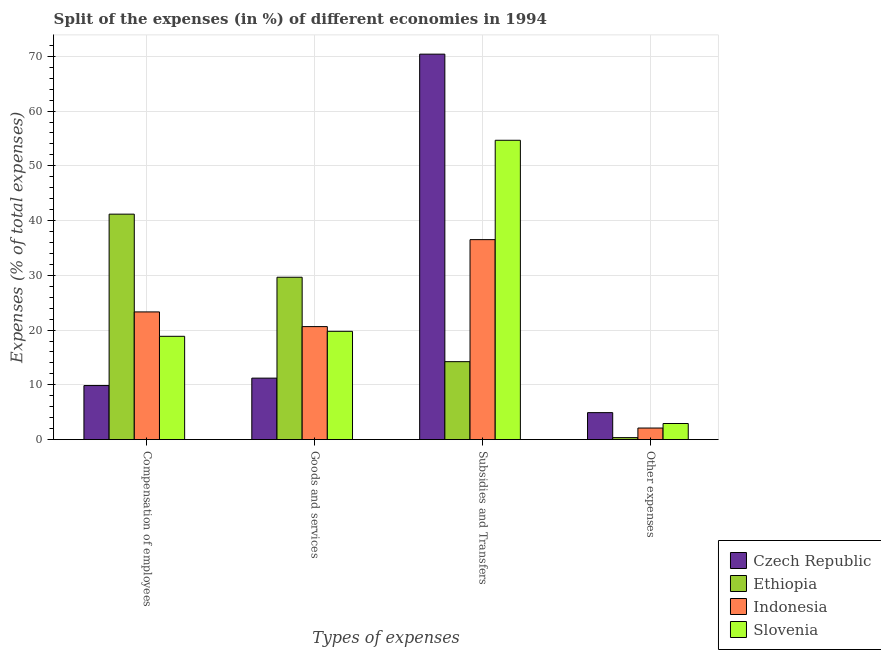How many different coloured bars are there?
Your answer should be very brief. 4. How many groups of bars are there?
Provide a short and direct response. 4. What is the label of the 4th group of bars from the left?
Provide a short and direct response. Other expenses. What is the percentage of amount spent on other expenses in Slovenia?
Your answer should be compact. 2.94. Across all countries, what is the maximum percentage of amount spent on other expenses?
Keep it short and to the point. 4.92. Across all countries, what is the minimum percentage of amount spent on subsidies?
Offer a very short reply. 14.23. In which country was the percentage of amount spent on other expenses maximum?
Your answer should be compact. Czech Republic. In which country was the percentage of amount spent on compensation of employees minimum?
Provide a short and direct response. Czech Republic. What is the total percentage of amount spent on compensation of employees in the graph?
Keep it short and to the point. 93.23. What is the difference between the percentage of amount spent on compensation of employees in Czech Republic and that in Slovenia?
Keep it short and to the point. -9. What is the difference between the percentage of amount spent on goods and services in Ethiopia and the percentage of amount spent on compensation of employees in Indonesia?
Make the answer very short. 6.33. What is the average percentage of amount spent on goods and services per country?
Make the answer very short. 20.32. What is the difference between the percentage of amount spent on subsidies and percentage of amount spent on compensation of employees in Ethiopia?
Your answer should be compact. -26.94. In how many countries, is the percentage of amount spent on goods and services greater than 28 %?
Keep it short and to the point. 1. What is the ratio of the percentage of amount spent on other expenses in Indonesia to that in Ethiopia?
Ensure brevity in your answer.  5.81. Is the difference between the percentage of amount spent on other expenses in Slovenia and Indonesia greater than the difference between the percentage of amount spent on subsidies in Slovenia and Indonesia?
Make the answer very short. No. What is the difference between the highest and the second highest percentage of amount spent on goods and services?
Offer a terse response. 9.02. What is the difference between the highest and the lowest percentage of amount spent on goods and services?
Keep it short and to the point. 18.42. Is the sum of the percentage of amount spent on goods and services in Ethiopia and Czech Republic greater than the maximum percentage of amount spent on subsidies across all countries?
Keep it short and to the point. No. Is it the case that in every country, the sum of the percentage of amount spent on other expenses and percentage of amount spent on subsidies is greater than the sum of percentage of amount spent on compensation of employees and percentage of amount spent on goods and services?
Provide a succinct answer. No. What does the 2nd bar from the left in Subsidies and Transfers represents?
Make the answer very short. Ethiopia. What does the 3rd bar from the right in Subsidies and Transfers represents?
Your answer should be very brief. Ethiopia. Is it the case that in every country, the sum of the percentage of amount spent on compensation of employees and percentage of amount spent on goods and services is greater than the percentage of amount spent on subsidies?
Offer a very short reply. No. How many countries are there in the graph?
Your answer should be very brief. 4. Does the graph contain grids?
Provide a succinct answer. Yes. Where does the legend appear in the graph?
Offer a terse response. Bottom right. How are the legend labels stacked?
Make the answer very short. Vertical. What is the title of the graph?
Offer a terse response. Split of the expenses (in %) of different economies in 1994. Does "Lesotho" appear as one of the legend labels in the graph?
Provide a short and direct response. No. What is the label or title of the X-axis?
Your response must be concise. Types of expenses. What is the label or title of the Y-axis?
Offer a terse response. Expenses (% of total expenses). What is the Expenses (% of total expenses) of Czech Republic in Compensation of employees?
Your answer should be very brief. 9.87. What is the Expenses (% of total expenses) of Ethiopia in Compensation of employees?
Offer a terse response. 41.18. What is the Expenses (% of total expenses) in Indonesia in Compensation of employees?
Your answer should be very brief. 23.32. What is the Expenses (% of total expenses) of Slovenia in Compensation of employees?
Give a very brief answer. 18.87. What is the Expenses (% of total expenses) in Czech Republic in Goods and services?
Offer a very short reply. 11.23. What is the Expenses (% of total expenses) of Ethiopia in Goods and services?
Your answer should be very brief. 29.65. What is the Expenses (% of total expenses) in Indonesia in Goods and services?
Make the answer very short. 20.64. What is the Expenses (% of total expenses) in Slovenia in Goods and services?
Ensure brevity in your answer.  19.78. What is the Expenses (% of total expenses) of Czech Republic in Subsidies and Transfers?
Keep it short and to the point. 70.4. What is the Expenses (% of total expenses) in Ethiopia in Subsidies and Transfers?
Offer a terse response. 14.23. What is the Expenses (% of total expenses) of Indonesia in Subsidies and Transfers?
Offer a very short reply. 36.52. What is the Expenses (% of total expenses) in Slovenia in Subsidies and Transfers?
Your response must be concise. 54.67. What is the Expenses (% of total expenses) of Czech Republic in Other expenses?
Your answer should be compact. 4.92. What is the Expenses (% of total expenses) in Ethiopia in Other expenses?
Your answer should be very brief. 0.36. What is the Expenses (% of total expenses) in Indonesia in Other expenses?
Keep it short and to the point. 2.11. What is the Expenses (% of total expenses) in Slovenia in Other expenses?
Your answer should be very brief. 2.94. Across all Types of expenses, what is the maximum Expenses (% of total expenses) in Czech Republic?
Provide a short and direct response. 70.4. Across all Types of expenses, what is the maximum Expenses (% of total expenses) in Ethiopia?
Offer a terse response. 41.18. Across all Types of expenses, what is the maximum Expenses (% of total expenses) of Indonesia?
Provide a succinct answer. 36.52. Across all Types of expenses, what is the maximum Expenses (% of total expenses) of Slovenia?
Provide a succinct answer. 54.67. Across all Types of expenses, what is the minimum Expenses (% of total expenses) in Czech Republic?
Offer a terse response. 4.92. Across all Types of expenses, what is the minimum Expenses (% of total expenses) of Ethiopia?
Give a very brief answer. 0.36. Across all Types of expenses, what is the minimum Expenses (% of total expenses) in Indonesia?
Ensure brevity in your answer.  2.11. Across all Types of expenses, what is the minimum Expenses (% of total expenses) of Slovenia?
Keep it short and to the point. 2.94. What is the total Expenses (% of total expenses) in Czech Republic in the graph?
Keep it short and to the point. 96.42. What is the total Expenses (% of total expenses) of Ethiopia in the graph?
Offer a terse response. 85.43. What is the total Expenses (% of total expenses) in Indonesia in the graph?
Offer a terse response. 82.59. What is the total Expenses (% of total expenses) of Slovenia in the graph?
Your answer should be compact. 96.25. What is the difference between the Expenses (% of total expenses) in Czech Republic in Compensation of employees and that in Goods and services?
Offer a terse response. -1.36. What is the difference between the Expenses (% of total expenses) of Ethiopia in Compensation of employees and that in Goods and services?
Provide a succinct answer. 11.52. What is the difference between the Expenses (% of total expenses) in Indonesia in Compensation of employees and that in Goods and services?
Give a very brief answer. 2.68. What is the difference between the Expenses (% of total expenses) in Slovenia in Compensation of employees and that in Goods and services?
Give a very brief answer. -0.91. What is the difference between the Expenses (% of total expenses) of Czech Republic in Compensation of employees and that in Subsidies and Transfers?
Offer a terse response. -60.53. What is the difference between the Expenses (% of total expenses) of Ethiopia in Compensation of employees and that in Subsidies and Transfers?
Provide a succinct answer. 26.94. What is the difference between the Expenses (% of total expenses) of Indonesia in Compensation of employees and that in Subsidies and Transfers?
Your response must be concise. -13.2. What is the difference between the Expenses (% of total expenses) of Slovenia in Compensation of employees and that in Subsidies and Transfers?
Offer a very short reply. -35.8. What is the difference between the Expenses (% of total expenses) of Czech Republic in Compensation of employees and that in Other expenses?
Offer a very short reply. 4.95. What is the difference between the Expenses (% of total expenses) in Ethiopia in Compensation of employees and that in Other expenses?
Your answer should be compact. 40.81. What is the difference between the Expenses (% of total expenses) in Indonesia in Compensation of employees and that in Other expenses?
Your response must be concise. 21.21. What is the difference between the Expenses (% of total expenses) of Slovenia in Compensation of employees and that in Other expenses?
Offer a very short reply. 15.93. What is the difference between the Expenses (% of total expenses) of Czech Republic in Goods and services and that in Subsidies and Transfers?
Provide a short and direct response. -59.17. What is the difference between the Expenses (% of total expenses) in Ethiopia in Goods and services and that in Subsidies and Transfers?
Your answer should be compact. 15.42. What is the difference between the Expenses (% of total expenses) of Indonesia in Goods and services and that in Subsidies and Transfers?
Ensure brevity in your answer.  -15.88. What is the difference between the Expenses (% of total expenses) of Slovenia in Goods and services and that in Subsidies and Transfers?
Give a very brief answer. -34.89. What is the difference between the Expenses (% of total expenses) in Czech Republic in Goods and services and that in Other expenses?
Your answer should be compact. 6.3. What is the difference between the Expenses (% of total expenses) of Ethiopia in Goods and services and that in Other expenses?
Provide a short and direct response. 29.29. What is the difference between the Expenses (% of total expenses) in Indonesia in Goods and services and that in Other expenses?
Offer a terse response. 18.53. What is the difference between the Expenses (% of total expenses) of Slovenia in Goods and services and that in Other expenses?
Keep it short and to the point. 16.83. What is the difference between the Expenses (% of total expenses) in Czech Republic in Subsidies and Transfers and that in Other expenses?
Keep it short and to the point. 65.47. What is the difference between the Expenses (% of total expenses) of Ethiopia in Subsidies and Transfers and that in Other expenses?
Offer a terse response. 13.87. What is the difference between the Expenses (% of total expenses) in Indonesia in Subsidies and Transfers and that in Other expenses?
Provide a succinct answer. 34.41. What is the difference between the Expenses (% of total expenses) in Slovenia in Subsidies and Transfers and that in Other expenses?
Your answer should be compact. 51.73. What is the difference between the Expenses (% of total expenses) of Czech Republic in Compensation of employees and the Expenses (% of total expenses) of Ethiopia in Goods and services?
Provide a succinct answer. -19.78. What is the difference between the Expenses (% of total expenses) in Czech Republic in Compensation of employees and the Expenses (% of total expenses) in Indonesia in Goods and services?
Make the answer very short. -10.77. What is the difference between the Expenses (% of total expenses) of Czech Republic in Compensation of employees and the Expenses (% of total expenses) of Slovenia in Goods and services?
Make the answer very short. -9.9. What is the difference between the Expenses (% of total expenses) of Ethiopia in Compensation of employees and the Expenses (% of total expenses) of Indonesia in Goods and services?
Make the answer very short. 20.54. What is the difference between the Expenses (% of total expenses) in Ethiopia in Compensation of employees and the Expenses (% of total expenses) in Slovenia in Goods and services?
Offer a terse response. 21.4. What is the difference between the Expenses (% of total expenses) of Indonesia in Compensation of employees and the Expenses (% of total expenses) of Slovenia in Goods and services?
Your answer should be very brief. 3.55. What is the difference between the Expenses (% of total expenses) in Czech Republic in Compensation of employees and the Expenses (% of total expenses) in Ethiopia in Subsidies and Transfers?
Your answer should be compact. -4.36. What is the difference between the Expenses (% of total expenses) of Czech Republic in Compensation of employees and the Expenses (% of total expenses) of Indonesia in Subsidies and Transfers?
Ensure brevity in your answer.  -26.65. What is the difference between the Expenses (% of total expenses) in Czech Republic in Compensation of employees and the Expenses (% of total expenses) in Slovenia in Subsidies and Transfers?
Make the answer very short. -44.8. What is the difference between the Expenses (% of total expenses) in Ethiopia in Compensation of employees and the Expenses (% of total expenses) in Indonesia in Subsidies and Transfers?
Offer a very short reply. 4.66. What is the difference between the Expenses (% of total expenses) in Ethiopia in Compensation of employees and the Expenses (% of total expenses) in Slovenia in Subsidies and Transfers?
Your answer should be compact. -13.49. What is the difference between the Expenses (% of total expenses) of Indonesia in Compensation of employees and the Expenses (% of total expenses) of Slovenia in Subsidies and Transfers?
Give a very brief answer. -31.35. What is the difference between the Expenses (% of total expenses) in Czech Republic in Compensation of employees and the Expenses (% of total expenses) in Ethiopia in Other expenses?
Give a very brief answer. 9.51. What is the difference between the Expenses (% of total expenses) in Czech Republic in Compensation of employees and the Expenses (% of total expenses) in Indonesia in Other expenses?
Make the answer very short. 7.76. What is the difference between the Expenses (% of total expenses) of Czech Republic in Compensation of employees and the Expenses (% of total expenses) of Slovenia in Other expenses?
Make the answer very short. 6.93. What is the difference between the Expenses (% of total expenses) in Ethiopia in Compensation of employees and the Expenses (% of total expenses) in Indonesia in Other expenses?
Your answer should be very brief. 39.06. What is the difference between the Expenses (% of total expenses) of Ethiopia in Compensation of employees and the Expenses (% of total expenses) of Slovenia in Other expenses?
Your answer should be compact. 38.23. What is the difference between the Expenses (% of total expenses) in Indonesia in Compensation of employees and the Expenses (% of total expenses) in Slovenia in Other expenses?
Your answer should be compact. 20.38. What is the difference between the Expenses (% of total expenses) in Czech Republic in Goods and services and the Expenses (% of total expenses) in Ethiopia in Subsidies and Transfers?
Keep it short and to the point. -3.01. What is the difference between the Expenses (% of total expenses) of Czech Republic in Goods and services and the Expenses (% of total expenses) of Indonesia in Subsidies and Transfers?
Your response must be concise. -25.29. What is the difference between the Expenses (% of total expenses) in Czech Republic in Goods and services and the Expenses (% of total expenses) in Slovenia in Subsidies and Transfers?
Provide a succinct answer. -43.44. What is the difference between the Expenses (% of total expenses) of Ethiopia in Goods and services and the Expenses (% of total expenses) of Indonesia in Subsidies and Transfers?
Your response must be concise. -6.87. What is the difference between the Expenses (% of total expenses) of Ethiopia in Goods and services and the Expenses (% of total expenses) of Slovenia in Subsidies and Transfers?
Provide a short and direct response. -25.01. What is the difference between the Expenses (% of total expenses) in Indonesia in Goods and services and the Expenses (% of total expenses) in Slovenia in Subsidies and Transfers?
Offer a very short reply. -34.03. What is the difference between the Expenses (% of total expenses) of Czech Republic in Goods and services and the Expenses (% of total expenses) of Ethiopia in Other expenses?
Your response must be concise. 10.86. What is the difference between the Expenses (% of total expenses) in Czech Republic in Goods and services and the Expenses (% of total expenses) in Indonesia in Other expenses?
Make the answer very short. 9.12. What is the difference between the Expenses (% of total expenses) of Czech Republic in Goods and services and the Expenses (% of total expenses) of Slovenia in Other expenses?
Keep it short and to the point. 8.29. What is the difference between the Expenses (% of total expenses) of Ethiopia in Goods and services and the Expenses (% of total expenses) of Indonesia in Other expenses?
Give a very brief answer. 27.54. What is the difference between the Expenses (% of total expenses) in Ethiopia in Goods and services and the Expenses (% of total expenses) in Slovenia in Other expenses?
Keep it short and to the point. 26.71. What is the difference between the Expenses (% of total expenses) in Indonesia in Goods and services and the Expenses (% of total expenses) in Slovenia in Other expenses?
Make the answer very short. 17.7. What is the difference between the Expenses (% of total expenses) in Czech Republic in Subsidies and Transfers and the Expenses (% of total expenses) in Ethiopia in Other expenses?
Your response must be concise. 70.03. What is the difference between the Expenses (% of total expenses) of Czech Republic in Subsidies and Transfers and the Expenses (% of total expenses) of Indonesia in Other expenses?
Give a very brief answer. 68.28. What is the difference between the Expenses (% of total expenses) of Czech Republic in Subsidies and Transfers and the Expenses (% of total expenses) of Slovenia in Other expenses?
Ensure brevity in your answer.  67.46. What is the difference between the Expenses (% of total expenses) of Ethiopia in Subsidies and Transfers and the Expenses (% of total expenses) of Indonesia in Other expenses?
Give a very brief answer. 12.12. What is the difference between the Expenses (% of total expenses) in Ethiopia in Subsidies and Transfers and the Expenses (% of total expenses) in Slovenia in Other expenses?
Offer a terse response. 11.29. What is the difference between the Expenses (% of total expenses) of Indonesia in Subsidies and Transfers and the Expenses (% of total expenses) of Slovenia in Other expenses?
Make the answer very short. 33.58. What is the average Expenses (% of total expenses) of Czech Republic per Types of expenses?
Ensure brevity in your answer.  24.11. What is the average Expenses (% of total expenses) of Ethiopia per Types of expenses?
Make the answer very short. 21.36. What is the average Expenses (% of total expenses) in Indonesia per Types of expenses?
Your answer should be compact. 20.65. What is the average Expenses (% of total expenses) in Slovenia per Types of expenses?
Give a very brief answer. 24.06. What is the difference between the Expenses (% of total expenses) of Czech Republic and Expenses (% of total expenses) of Ethiopia in Compensation of employees?
Your answer should be very brief. -31.3. What is the difference between the Expenses (% of total expenses) in Czech Republic and Expenses (% of total expenses) in Indonesia in Compensation of employees?
Provide a short and direct response. -13.45. What is the difference between the Expenses (% of total expenses) in Czech Republic and Expenses (% of total expenses) in Slovenia in Compensation of employees?
Make the answer very short. -9. What is the difference between the Expenses (% of total expenses) of Ethiopia and Expenses (% of total expenses) of Indonesia in Compensation of employees?
Ensure brevity in your answer.  17.85. What is the difference between the Expenses (% of total expenses) of Ethiopia and Expenses (% of total expenses) of Slovenia in Compensation of employees?
Provide a short and direct response. 22.31. What is the difference between the Expenses (% of total expenses) of Indonesia and Expenses (% of total expenses) of Slovenia in Compensation of employees?
Keep it short and to the point. 4.45. What is the difference between the Expenses (% of total expenses) of Czech Republic and Expenses (% of total expenses) of Ethiopia in Goods and services?
Give a very brief answer. -18.42. What is the difference between the Expenses (% of total expenses) in Czech Republic and Expenses (% of total expenses) in Indonesia in Goods and services?
Give a very brief answer. -9.41. What is the difference between the Expenses (% of total expenses) of Czech Republic and Expenses (% of total expenses) of Slovenia in Goods and services?
Keep it short and to the point. -8.55. What is the difference between the Expenses (% of total expenses) of Ethiopia and Expenses (% of total expenses) of Indonesia in Goods and services?
Make the answer very short. 9.02. What is the difference between the Expenses (% of total expenses) of Ethiopia and Expenses (% of total expenses) of Slovenia in Goods and services?
Ensure brevity in your answer.  9.88. What is the difference between the Expenses (% of total expenses) in Indonesia and Expenses (% of total expenses) in Slovenia in Goods and services?
Your answer should be compact. 0.86. What is the difference between the Expenses (% of total expenses) in Czech Republic and Expenses (% of total expenses) in Ethiopia in Subsidies and Transfers?
Ensure brevity in your answer.  56.16. What is the difference between the Expenses (% of total expenses) in Czech Republic and Expenses (% of total expenses) in Indonesia in Subsidies and Transfers?
Make the answer very short. 33.88. What is the difference between the Expenses (% of total expenses) in Czech Republic and Expenses (% of total expenses) in Slovenia in Subsidies and Transfers?
Provide a short and direct response. 15.73. What is the difference between the Expenses (% of total expenses) in Ethiopia and Expenses (% of total expenses) in Indonesia in Subsidies and Transfers?
Your response must be concise. -22.29. What is the difference between the Expenses (% of total expenses) in Ethiopia and Expenses (% of total expenses) in Slovenia in Subsidies and Transfers?
Your answer should be compact. -40.43. What is the difference between the Expenses (% of total expenses) in Indonesia and Expenses (% of total expenses) in Slovenia in Subsidies and Transfers?
Give a very brief answer. -18.15. What is the difference between the Expenses (% of total expenses) in Czech Republic and Expenses (% of total expenses) in Ethiopia in Other expenses?
Provide a succinct answer. 4.56. What is the difference between the Expenses (% of total expenses) of Czech Republic and Expenses (% of total expenses) of Indonesia in Other expenses?
Keep it short and to the point. 2.81. What is the difference between the Expenses (% of total expenses) in Czech Republic and Expenses (% of total expenses) in Slovenia in Other expenses?
Your answer should be very brief. 1.98. What is the difference between the Expenses (% of total expenses) in Ethiopia and Expenses (% of total expenses) in Indonesia in Other expenses?
Your answer should be compact. -1.75. What is the difference between the Expenses (% of total expenses) of Ethiopia and Expenses (% of total expenses) of Slovenia in Other expenses?
Your answer should be very brief. -2.58. What is the difference between the Expenses (% of total expenses) of Indonesia and Expenses (% of total expenses) of Slovenia in Other expenses?
Your response must be concise. -0.83. What is the ratio of the Expenses (% of total expenses) of Czech Republic in Compensation of employees to that in Goods and services?
Your answer should be compact. 0.88. What is the ratio of the Expenses (% of total expenses) of Ethiopia in Compensation of employees to that in Goods and services?
Your answer should be compact. 1.39. What is the ratio of the Expenses (% of total expenses) of Indonesia in Compensation of employees to that in Goods and services?
Your answer should be compact. 1.13. What is the ratio of the Expenses (% of total expenses) in Slovenia in Compensation of employees to that in Goods and services?
Make the answer very short. 0.95. What is the ratio of the Expenses (% of total expenses) in Czech Republic in Compensation of employees to that in Subsidies and Transfers?
Provide a short and direct response. 0.14. What is the ratio of the Expenses (% of total expenses) of Ethiopia in Compensation of employees to that in Subsidies and Transfers?
Your answer should be compact. 2.89. What is the ratio of the Expenses (% of total expenses) of Indonesia in Compensation of employees to that in Subsidies and Transfers?
Offer a terse response. 0.64. What is the ratio of the Expenses (% of total expenses) in Slovenia in Compensation of employees to that in Subsidies and Transfers?
Give a very brief answer. 0.35. What is the ratio of the Expenses (% of total expenses) in Czech Republic in Compensation of employees to that in Other expenses?
Ensure brevity in your answer.  2. What is the ratio of the Expenses (% of total expenses) of Ethiopia in Compensation of employees to that in Other expenses?
Your response must be concise. 113.38. What is the ratio of the Expenses (% of total expenses) of Indonesia in Compensation of employees to that in Other expenses?
Your answer should be compact. 11.05. What is the ratio of the Expenses (% of total expenses) of Slovenia in Compensation of employees to that in Other expenses?
Your answer should be compact. 6.42. What is the ratio of the Expenses (% of total expenses) in Czech Republic in Goods and services to that in Subsidies and Transfers?
Make the answer very short. 0.16. What is the ratio of the Expenses (% of total expenses) in Ethiopia in Goods and services to that in Subsidies and Transfers?
Your answer should be very brief. 2.08. What is the ratio of the Expenses (% of total expenses) of Indonesia in Goods and services to that in Subsidies and Transfers?
Make the answer very short. 0.57. What is the ratio of the Expenses (% of total expenses) in Slovenia in Goods and services to that in Subsidies and Transfers?
Your answer should be very brief. 0.36. What is the ratio of the Expenses (% of total expenses) in Czech Republic in Goods and services to that in Other expenses?
Your answer should be very brief. 2.28. What is the ratio of the Expenses (% of total expenses) in Ethiopia in Goods and services to that in Other expenses?
Ensure brevity in your answer.  81.65. What is the ratio of the Expenses (% of total expenses) in Indonesia in Goods and services to that in Other expenses?
Ensure brevity in your answer.  9.77. What is the ratio of the Expenses (% of total expenses) of Slovenia in Goods and services to that in Other expenses?
Ensure brevity in your answer.  6.72. What is the ratio of the Expenses (% of total expenses) of Czech Republic in Subsidies and Transfers to that in Other expenses?
Your response must be concise. 14.29. What is the ratio of the Expenses (% of total expenses) in Ethiopia in Subsidies and Transfers to that in Other expenses?
Offer a terse response. 39.19. What is the ratio of the Expenses (% of total expenses) in Indonesia in Subsidies and Transfers to that in Other expenses?
Make the answer very short. 17.3. What is the ratio of the Expenses (% of total expenses) of Slovenia in Subsidies and Transfers to that in Other expenses?
Ensure brevity in your answer.  18.59. What is the difference between the highest and the second highest Expenses (% of total expenses) of Czech Republic?
Offer a very short reply. 59.17. What is the difference between the highest and the second highest Expenses (% of total expenses) of Ethiopia?
Offer a very short reply. 11.52. What is the difference between the highest and the second highest Expenses (% of total expenses) of Indonesia?
Offer a very short reply. 13.2. What is the difference between the highest and the second highest Expenses (% of total expenses) in Slovenia?
Make the answer very short. 34.89. What is the difference between the highest and the lowest Expenses (% of total expenses) of Czech Republic?
Offer a terse response. 65.47. What is the difference between the highest and the lowest Expenses (% of total expenses) of Ethiopia?
Provide a short and direct response. 40.81. What is the difference between the highest and the lowest Expenses (% of total expenses) in Indonesia?
Provide a short and direct response. 34.41. What is the difference between the highest and the lowest Expenses (% of total expenses) in Slovenia?
Ensure brevity in your answer.  51.73. 